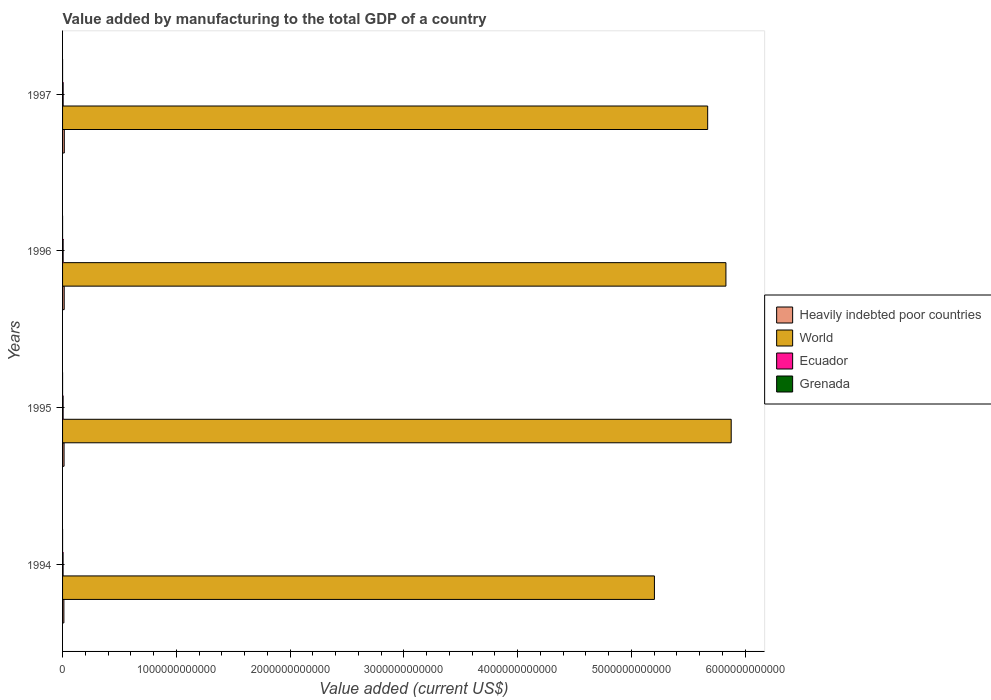How many different coloured bars are there?
Your response must be concise. 4. Are the number of bars per tick equal to the number of legend labels?
Provide a succinct answer. Yes. How many bars are there on the 3rd tick from the top?
Provide a short and direct response. 4. How many bars are there on the 1st tick from the bottom?
Provide a succinct answer. 4. What is the value added by manufacturing to the total GDP in World in 1996?
Make the answer very short. 5.83e+12. Across all years, what is the maximum value added by manufacturing to the total GDP in Heavily indebted poor countries?
Your answer should be compact. 1.53e+1. Across all years, what is the minimum value added by manufacturing to the total GDP in World?
Provide a succinct answer. 5.20e+12. What is the total value added by manufacturing to the total GDP in Ecuador in the graph?
Offer a very short reply. 1.94e+1. What is the difference between the value added by manufacturing to the total GDP in Ecuador in 1995 and that in 1997?
Ensure brevity in your answer.  -2.62e+08. What is the difference between the value added by manufacturing to the total GDP in Ecuador in 1996 and the value added by manufacturing to the total GDP in Grenada in 1995?
Provide a short and direct response. 4.92e+09. What is the average value added by manufacturing to the total GDP in Grenada per year?
Provide a short and direct response. 1.58e+07. In the year 1995, what is the difference between the value added by manufacturing to the total GDP in Ecuador and value added by manufacturing to the total GDP in World?
Your response must be concise. -5.87e+12. In how many years, is the value added by manufacturing to the total GDP in Grenada greater than 3400000000000 US$?
Ensure brevity in your answer.  0. What is the ratio of the value added by manufacturing to the total GDP in Heavily indebted poor countries in 1996 to that in 1997?
Keep it short and to the point. 0.94. What is the difference between the highest and the second highest value added by manufacturing to the total GDP in Heavily indebted poor countries?
Your response must be concise. 8.52e+08. What is the difference between the highest and the lowest value added by manufacturing to the total GDP in Ecuador?
Your response must be concise. 5.12e+08. In how many years, is the value added by manufacturing to the total GDP in World greater than the average value added by manufacturing to the total GDP in World taken over all years?
Your response must be concise. 3. What does the 2nd bar from the top in 1994 represents?
Your response must be concise. Ecuador. What does the 2nd bar from the bottom in 1994 represents?
Provide a succinct answer. World. Is it the case that in every year, the sum of the value added by manufacturing to the total GDP in Heavily indebted poor countries and value added by manufacturing to the total GDP in Ecuador is greater than the value added by manufacturing to the total GDP in Grenada?
Offer a very short reply. Yes. How many bars are there?
Provide a succinct answer. 16. What is the difference between two consecutive major ticks on the X-axis?
Make the answer very short. 1.00e+12. Does the graph contain any zero values?
Provide a short and direct response. No. How many legend labels are there?
Provide a succinct answer. 4. How are the legend labels stacked?
Provide a succinct answer. Vertical. What is the title of the graph?
Give a very brief answer. Value added by manufacturing to the total GDP of a country. Does "Uzbekistan" appear as one of the legend labels in the graph?
Provide a short and direct response. No. What is the label or title of the X-axis?
Keep it short and to the point. Value added (current US$). What is the label or title of the Y-axis?
Provide a succinct answer. Years. What is the Value added (current US$) of Heavily indebted poor countries in 1994?
Provide a succinct answer. 1.17e+1. What is the Value added (current US$) in World in 1994?
Give a very brief answer. 5.20e+12. What is the Value added (current US$) in Ecuador in 1994?
Provide a succinct answer. 4.56e+09. What is the Value added (current US$) in Grenada in 1994?
Give a very brief answer. 1.39e+07. What is the Value added (current US$) in Heavily indebted poor countries in 1995?
Ensure brevity in your answer.  1.31e+1. What is the Value added (current US$) of World in 1995?
Your response must be concise. 5.88e+12. What is the Value added (current US$) of Ecuador in 1995?
Provide a short and direct response. 4.81e+09. What is the Value added (current US$) of Grenada in 1995?
Provide a succinct answer. 1.54e+07. What is the Value added (current US$) in Heavily indebted poor countries in 1996?
Keep it short and to the point. 1.44e+1. What is the Value added (current US$) of World in 1996?
Offer a terse response. 5.83e+12. What is the Value added (current US$) in Ecuador in 1996?
Offer a very short reply. 4.94e+09. What is the Value added (current US$) of Grenada in 1996?
Your answer should be very brief. 1.66e+07. What is the Value added (current US$) in Heavily indebted poor countries in 1997?
Offer a terse response. 1.53e+1. What is the Value added (current US$) of World in 1997?
Offer a very short reply. 5.67e+12. What is the Value added (current US$) in Ecuador in 1997?
Your answer should be very brief. 5.07e+09. What is the Value added (current US$) of Grenada in 1997?
Your answer should be very brief. 1.75e+07. Across all years, what is the maximum Value added (current US$) in Heavily indebted poor countries?
Make the answer very short. 1.53e+1. Across all years, what is the maximum Value added (current US$) of World?
Ensure brevity in your answer.  5.88e+12. Across all years, what is the maximum Value added (current US$) in Ecuador?
Offer a very short reply. 5.07e+09. Across all years, what is the maximum Value added (current US$) in Grenada?
Keep it short and to the point. 1.75e+07. Across all years, what is the minimum Value added (current US$) in Heavily indebted poor countries?
Your answer should be very brief. 1.17e+1. Across all years, what is the minimum Value added (current US$) of World?
Offer a very short reply. 5.20e+12. Across all years, what is the minimum Value added (current US$) of Ecuador?
Your answer should be very brief. 4.56e+09. Across all years, what is the minimum Value added (current US$) of Grenada?
Keep it short and to the point. 1.39e+07. What is the total Value added (current US$) of Heavily indebted poor countries in the graph?
Your response must be concise. 5.44e+1. What is the total Value added (current US$) in World in the graph?
Provide a succinct answer. 2.26e+13. What is the total Value added (current US$) in Ecuador in the graph?
Provide a short and direct response. 1.94e+1. What is the total Value added (current US$) of Grenada in the graph?
Offer a very short reply. 6.34e+07. What is the difference between the Value added (current US$) of Heavily indebted poor countries in 1994 and that in 1995?
Provide a short and direct response. -1.46e+09. What is the difference between the Value added (current US$) of World in 1994 and that in 1995?
Ensure brevity in your answer.  -6.75e+11. What is the difference between the Value added (current US$) of Ecuador in 1994 and that in 1995?
Give a very brief answer. -2.51e+08. What is the difference between the Value added (current US$) of Grenada in 1994 and that in 1995?
Give a very brief answer. -1.42e+06. What is the difference between the Value added (current US$) of Heavily indebted poor countries in 1994 and that in 1996?
Provide a succinct answer. -2.75e+09. What is the difference between the Value added (current US$) in World in 1994 and that in 1996?
Give a very brief answer. -6.28e+11. What is the difference between the Value added (current US$) of Ecuador in 1994 and that in 1996?
Offer a very short reply. -3.81e+08. What is the difference between the Value added (current US$) in Grenada in 1994 and that in 1996?
Provide a short and direct response. -2.63e+06. What is the difference between the Value added (current US$) in Heavily indebted poor countries in 1994 and that in 1997?
Provide a short and direct response. -3.61e+09. What is the difference between the Value added (current US$) of World in 1994 and that in 1997?
Ensure brevity in your answer.  -4.68e+11. What is the difference between the Value added (current US$) in Ecuador in 1994 and that in 1997?
Offer a terse response. -5.12e+08. What is the difference between the Value added (current US$) in Grenada in 1994 and that in 1997?
Your answer should be very brief. -3.52e+06. What is the difference between the Value added (current US$) of Heavily indebted poor countries in 1995 and that in 1996?
Offer a terse response. -1.29e+09. What is the difference between the Value added (current US$) in World in 1995 and that in 1996?
Ensure brevity in your answer.  4.64e+1. What is the difference between the Value added (current US$) in Ecuador in 1995 and that in 1996?
Your answer should be compact. -1.31e+08. What is the difference between the Value added (current US$) of Grenada in 1995 and that in 1996?
Your response must be concise. -1.21e+06. What is the difference between the Value added (current US$) in Heavily indebted poor countries in 1995 and that in 1997?
Offer a terse response. -2.15e+09. What is the difference between the Value added (current US$) of World in 1995 and that in 1997?
Provide a succinct answer. 2.07e+11. What is the difference between the Value added (current US$) in Ecuador in 1995 and that in 1997?
Your response must be concise. -2.62e+08. What is the difference between the Value added (current US$) of Grenada in 1995 and that in 1997?
Keep it short and to the point. -2.10e+06. What is the difference between the Value added (current US$) of Heavily indebted poor countries in 1996 and that in 1997?
Offer a very short reply. -8.52e+08. What is the difference between the Value added (current US$) in World in 1996 and that in 1997?
Ensure brevity in your answer.  1.60e+11. What is the difference between the Value added (current US$) of Ecuador in 1996 and that in 1997?
Provide a short and direct response. -1.31e+08. What is the difference between the Value added (current US$) of Grenada in 1996 and that in 1997?
Ensure brevity in your answer.  -8.89e+05. What is the difference between the Value added (current US$) of Heavily indebted poor countries in 1994 and the Value added (current US$) of World in 1995?
Provide a short and direct response. -5.87e+12. What is the difference between the Value added (current US$) of Heavily indebted poor countries in 1994 and the Value added (current US$) of Ecuador in 1995?
Give a very brief answer. 6.85e+09. What is the difference between the Value added (current US$) of Heavily indebted poor countries in 1994 and the Value added (current US$) of Grenada in 1995?
Your response must be concise. 1.16e+1. What is the difference between the Value added (current US$) in World in 1994 and the Value added (current US$) in Ecuador in 1995?
Give a very brief answer. 5.20e+12. What is the difference between the Value added (current US$) of World in 1994 and the Value added (current US$) of Grenada in 1995?
Provide a succinct answer. 5.20e+12. What is the difference between the Value added (current US$) of Ecuador in 1994 and the Value added (current US$) of Grenada in 1995?
Offer a terse response. 4.54e+09. What is the difference between the Value added (current US$) of Heavily indebted poor countries in 1994 and the Value added (current US$) of World in 1996?
Offer a very short reply. -5.82e+12. What is the difference between the Value added (current US$) of Heavily indebted poor countries in 1994 and the Value added (current US$) of Ecuador in 1996?
Offer a very short reply. 6.72e+09. What is the difference between the Value added (current US$) in Heavily indebted poor countries in 1994 and the Value added (current US$) in Grenada in 1996?
Your response must be concise. 1.16e+1. What is the difference between the Value added (current US$) of World in 1994 and the Value added (current US$) of Ecuador in 1996?
Ensure brevity in your answer.  5.20e+12. What is the difference between the Value added (current US$) of World in 1994 and the Value added (current US$) of Grenada in 1996?
Your response must be concise. 5.20e+12. What is the difference between the Value added (current US$) of Ecuador in 1994 and the Value added (current US$) of Grenada in 1996?
Make the answer very short. 4.54e+09. What is the difference between the Value added (current US$) in Heavily indebted poor countries in 1994 and the Value added (current US$) in World in 1997?
Ensure brevity in your answer.  -5.66e+12. What is the difference between the Value added (current US$) in Heavily indebted poor countries in 1994 and the Value added (current US$) in Ecuador in 1997?
Provide a short and direct response. 6.59e+09. What is the difference between the Value added (current US$) in Heavily indebted poor countries in 1994 and the Value added (current US$) in Grenada in 1997?
Offer a very short reply. 1.16e+1. What is the difference between the Value added (current US$) in World in 1994 and the Value added (current US$) in Ecuador in 1997?
Provide a short and direct response. 5.20e+12. What is the difference between the Value added (current US$) of World in 1994 and the Value added (current US$) of Grenada in 1997?
Ensure brevity in your answer.  5.20e+12. What is the difference between the Value added (current US$) of Ecuador in 1994 and the Value added (current US$) of Grenada in 1997?
Your response must be concise. 4.54e+09. What is the difference between the Value added (current US$) of Heavily indebted poor countries in 1995 and the Value added (current US$) of World in 1996?
Offer a terse response. -5.82e+12. What is the difference between the Value added (current US$) in Heavily indebted poor countries in 1995 and the Value added (current US$) in Ecuador in 1996?
Provide a short and direct response. 8.18e+09. What is the difference between the Value added (current US$) in Heavily indebted poor countries in 1995 and the Value added (current US$) in Grenada in 1996?
Give a very brief answer. 1.31e+1. What is the difference between the Value added (current US$) of World in 1995 and the Value added (current US$) of Ecuador in 1996?
Give a very brief answer. 5.87e+12. What is the difference between the Value added (current US$) in World in 1995 and the Value added (current US$) in Grenada in 1996?
Keep it short and to the point. 5.88e+12. What is the difference between the Value added (current US$) in Ecuador in 1995 and the Value added (current US$) in Grenada in 1996?
Offer a terse response. 4.79e+09. What is the difference between the Value added (current US$) in Heavily indebted poor countries in 1995 and the Value added (current US$) in World in 1997?
Your answer should be compact. -5.66e+12. What is the difference between the Value added (current US$) in Heavily indebted poor countries in 1995 and the Value added (current US$) in Ecuador in 1997?
Your response must be concise. 8.05e+09. What is the difference between the Value added (current US$) of Heavily indebted poor countries in 1995 and the Value added (current US$) of Grenada in 1997?
Provide a short and direct response. 1.31e+1. What is the difference between the Value added (current US$) in World in 1995 and the Value added (current US$) in Ecuador in 1997?
Keep it short and to the point. 5.87e+12. What is the difference between the Value added (current US$) of World in 1995 and the Value added (current US$) of Grenada in 1997?
Your answer should be very brief. 5.88e+12. What is the difference between the Value added (current US$) of Ecuador in 1995 and the Value added (current US$) of Grenada in 1997?
Keep it short and to the point. 4.79e+09. What is the difference between the Value added (current US$) of Heavily indebted poor countries in 1996 and the Value added (current US$) of World in 1997?
Your response must be concise. -5.66e+12. What is the difference between the Value added (current US$) of Heavily indebted poor countries in 1996 and the Value added (current US$) of Ecuador in 1997?
Your answer should be very brief. 9.34e+09. What is the difference between the Value added (current US$) of Heavily indebted poor countries in 1996 and the Value added (current US$) of Grenada in 1997?
Make the answer very short. 1.44e+1. What is the difference between the Value added (current US$) in World in 1996 and the Value added (current US$) in Ecuador in 1997?
Provide a succinct answer. 5.83e+12. What is the difference between the Value added (current US$) in World in 1996 and the Value added (current US$) in Grenada in 1997?
Provide a short and direct response. 5.83e+12. What is the difference between the Value added (current US$) in Ecuador in 1996 and the Value added (current US$) in Grenada in 1997?
Offer a very short reply. 4.92e+09. What is the average Value added (current US$) of Heavily indebted poor countries per year?
Your answer should be compact. 1.36e+1. What is the average Value added (current US$) of World per year?
Your answer should be compact. 5.65e+12. What is the average Value added (current US$) in Ecuador per year?
Ensure brevity in your answer.  4.84e+09. What is the average Value added (current US$) in Grenada per year?
Your answer should be compact. 1.58e+07. In the year 1994, what is the difference between the Value added (current US$) in Heavily indebted poor countries and Value added (current US$) in World?
Provide a short and direct response. -5.19e+12. In the year 1994, what is the difference between the Value added (current US$) in Heavily indebted poor countries and Value added (current US$) in Ecuador?
Provide a succinct answer. 7.10e+09. In the year 1994, what is the difference between the Value added (current US$) in Heavily indebted poor countries and Value added (current US$) in Grenada?
Provide a short and direct response. 1.16e+1. In the year 1994, what is the difference between the Value added (current US$) in World and Value added (current US$) in Ecuador?
Offer a very short reply. 5.20e+12. In the year 1994, what is the difference between the Value added (current US$) of World and Value added (current US$) of Grenada?
Your response must be concise. 5.20e+12. In the year 1994, what is the difference between the Value added (current US$) in Ecuador and Value added (current US$) in Grenada?
Give a very brief answer. 4.54e+09. In the year 1995, what is the difference between the Value added (current US$) of Heavily indebted poor countries and Value added (current US$) of World?
Offer a terse response. -5.86e+12. In the year 1995, what is the difference between the Value added (current US$) in Heavily indebted poor countries and Value added (current US$) in Ecuador?
Provide a short and direct response. 8.31e+09. In the year 1995, what is the difference between the Value added (current US$) in Heavily indebted poor countries and Value added (current US$) in Grenada?
Your answer should be compact. 1.31e+1. In the year 1995, what is the difference between the Value added (current US$) of World and Value added (current US$) of Ecuador?
Ensure brevity in your answer.  5.87e+12. In the year 1995, what is the difference between the Value added (current US$) of World and Value added (current US$) of Grenada?
Make the answer very short. 5.88e+12. In the year 1995, what is the difference between the Value added (current US$) in Ecuador and Value added (current US$) in Grenada?
Your answer should be compact. 4.79e+09. In the year 1996, what is the difference between the Value added (current US$) of Heavily indebted poor countries and Value added (current US$) of World?
Offer a very short reply. -5.82e+12. In the year 1996, what is the difference between the Value added (current US$) in Heavily indebted poor countries and Value added (current US$) in Ecuador?
Offer a terse response. 9.47e+09. In the year 1996, what is the difference between the Value added (current US$) in Heavily indebted poor countries and Value added (current US$) in Grenada?
Offer a terse response. 1.44e+1. In the year 1996, what is the difference between the Value added (current US$) of World and Value added (current US$) of Ecuador?
Keep it short and to the point. 5.83e+12. In the year 1996, what is the difference between the Value added (current US$) in World and Value added (current US$) in Grenada?
Make the answer very short. 5.83e+12. In the year 1996, what is the difference between the Value added (current US$) of Ecuador and Value added (current US$) of Grenada?
Give a very brief answer. 4.92e+09. In the year 1997, what is the difference between the Value added (current US$) in Heavily indebted poor countries and Value added (current US$) in World?
Offer a terse response. -5.66e+12. In the year 1997, what is the difference between the Value added (current US$) in Heavily indebted poor countries and Value added (current US$) in Ecuador?
Provide a short and direct response. 1.02e+1. In the year 1997, what is the difference between the Value added (current US$) of Heavily indebted poor countries and Value added (current US$) of Grenada?
Your answer should be compact. 1.52e+1. In the year 1997, what is the difference between the Value added (current US$) in World and Value added (current US$) in Ecuador?
Your response must be concise. 5.67e+12. In the year 1997, what is the difference between the Value added (current US$) in World and Value added (current US$) in Grenada?
Your response must be concise. 5.67e+12. In the year 1997, what is the difference between the Value added (current US$) of Ecuador and Value added (current US$) of Grenada?
Your answer should be very brief. 5.05e+09. What is the ratio of the Value added (current US$) in Heavily indebted poor countries in 1994 to that in 1995?
Make the answer very short. 0.89. What is the ratio of the Value added (current US$) in World in 1994 to that in 1995?
Provide a succinct answer. 0.89. What is the ratio of the Value added (current US$) in Ecuador in 1994 to that in 1995?
Give a very brief answer. 0.95. What is the ratio of the Value added (current US$) of Grenada in 1994 to that in 1995?
Ensure brevity in your answer.  0.91. What is the ratio of the Value added (current US$) of Heavily indebted poor countries in 1994 to that in 1996?
Make the answer very short. 0.81. What is the ratio of the Value added (current US$) in World in 1994 to that in 1996?
Give a very brief answer. 0.89. What is the ratio of the Value added (current US$) of Ecuador in 1994 to that in 1996?
Your answer should be very brief. 0.92. What is the ratio of the Value added (current US$) in Grenada in 1994 to that in 1996?
Provide a succinct answer. 0.84. What is the ratio of the Value added (current US$) in Heavily indebted poor countries in 1994 to that in 1997?
Your answer should be compact. 0.76. What is the ratio of the Value added (current US$) of World in 1994 to that in 1997?
Give a very brief answer. 0.92. What is the ratio of the Value added (current US$) in Ecuador in 1994 to that in 1997?
Your answer should be very brief. 0.9. What is the ratio of the Value added (current US$) in Grenada in 1994 to that in 1997?
Your response must be concise. 0.8. What is the ratio of the Value added (current US$) of Heavily indebted poor countries in 1995 to that in 1996?
Provide a succinct answer. 0.91. What is the ratio of the Value added (current US$) in Ecuador in 1995 to that in 1996?
Your answer should be compact. 0.97. What is the ratio of the Value added (current US$) in Grenada in 1995 to that in 1996?
Provide a succinct answer. 0.93. What is the ratio of the Value added (current US$) of Heavily indebted poor countries in 1995 to that in 1997?
Your answer should be very brief. 0.86. What is the ratio of the Value added (current US$) in World in 1995 to that in 1997?
Give a very brief answer. 1.04. What is the ratio of the Value added (current US$) of Ecuador in 1995 to that in 1997?
Give a very brief answer. 0.95. What is the ratio of the Value added (current US$) of Grenada in 1995 to that in 1997?
Your response must be concise. 0.88. What is the ratio of the Value added (current US$) of Heavily indebted poor countries in 1996 to that in 1997?
Ensure brevity in your answer.  0.94. What is the ratio of the Value added (current US$) in World in 1996 to that in 1997?
Give a very brief answer. 1.03. What is the ratio of the Value added (current US$) of Ecuador in 1996 to that in 1997?
Offer a terse response. 0.97. What is the ratio of the Value added (current US$) of Grenada in 1996 to that in 1997?
Your answer should be compact. 0.95. What is the difference between the highest and the second highest Value added (current US$) in Heavily indebted poor countries?
Give a very brief answer. 8.52e+08. What is the difference between the highest and the second highest Value added (current US$) in World?
Make the answer very short. 4.64e+1. What is the difference between the highest and the second highest Value added (current US$) of Ecuador?
Ensure brevity in your answer.  1.31e+08. What is the difference between the highest and the second highest Value added (current US$) of Grenada?
Ensure brevity in your answer.  8.89e+05. What is the difference between the highest and the lowest Value added (current US$) of Heavily indebted poor countries?
Your answer should be very brief. 3.61e+09. What is the difference between the highest and the lowest Value added (current US$) in World?
Provide a succinct answer. 6.75e+11. What is the difference between the highest and the lowest Value added (current US$) of Ecuador?
Give a very brief answer. 5.12e+08. What is the difference between the highest and the lowest Value added (current US$) of Grenada?
Give a very brief answer. 3.52e+06. 